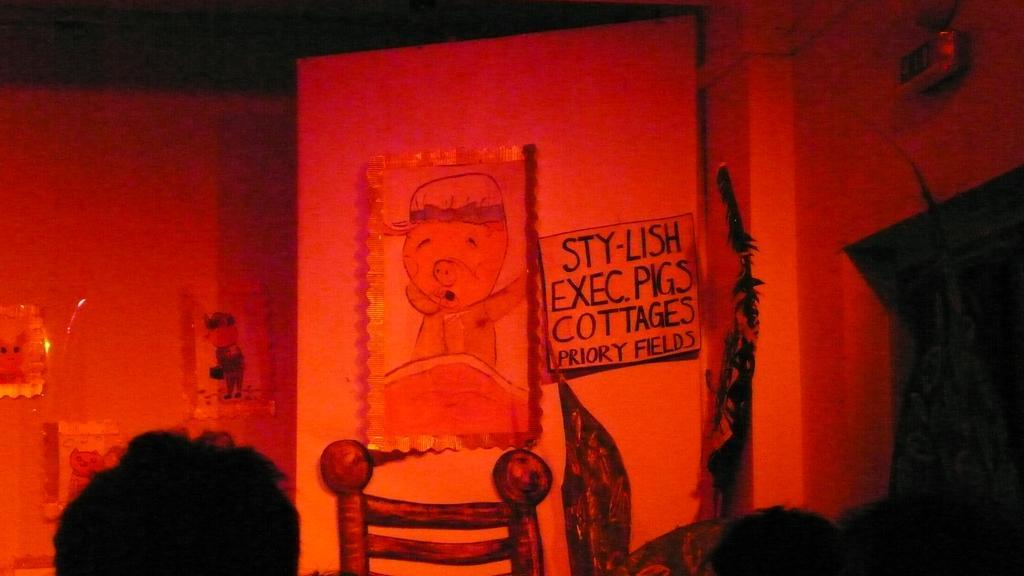Describe this image in one or two sentences. This image is taken indoors. In the middle of the image there is a wall with a few posters with cats on them and there is a poster with a text on it. At the bottom of the image there is a painting of a chair on the wall and there is a person. 